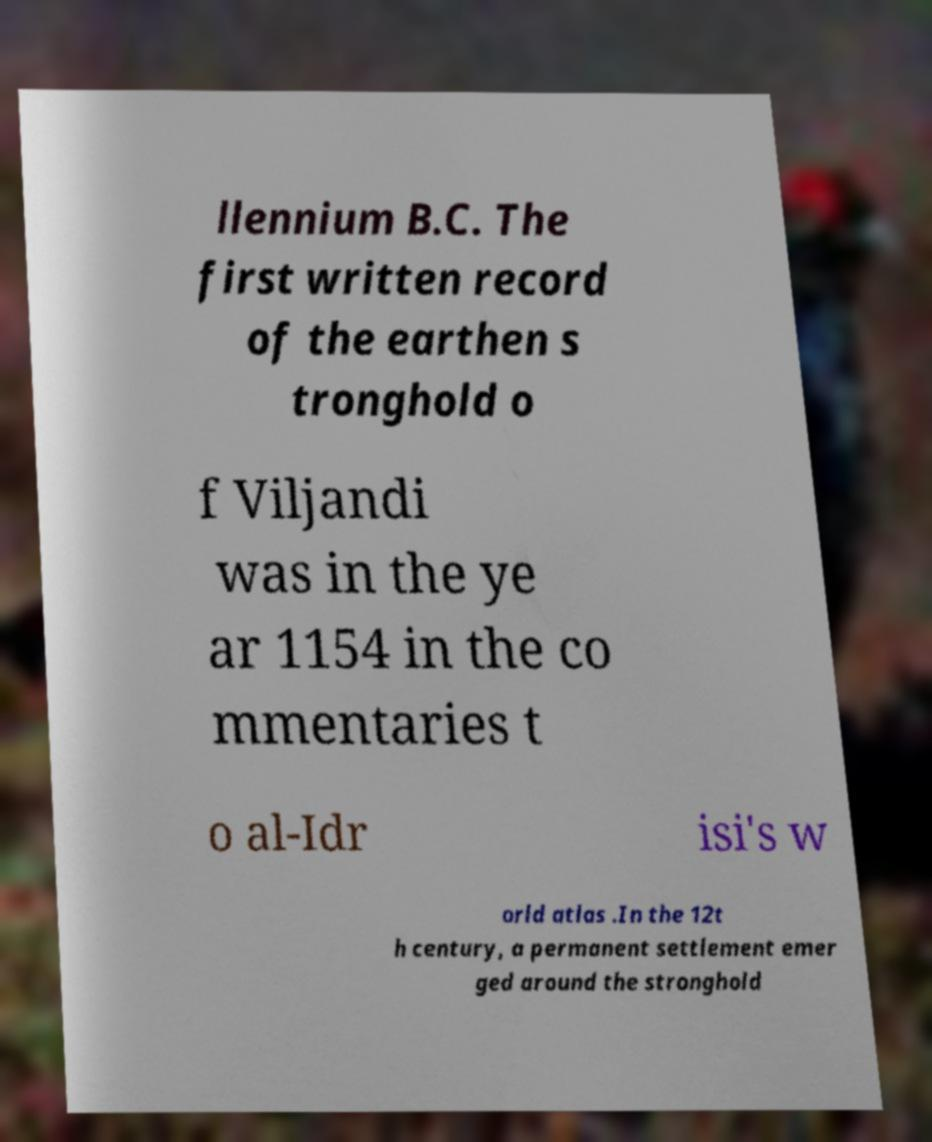Could you assist in decoding the text presented in this image and type it out clearly? llennium B.C. The first written record of the earthen s tronghold o f Viljandi was in the ye ar 1154 in the co mmentaries t o al-Idr isi's w orld atlas .In the 12t h century, a permanent settlement emer ged around the stronghold 